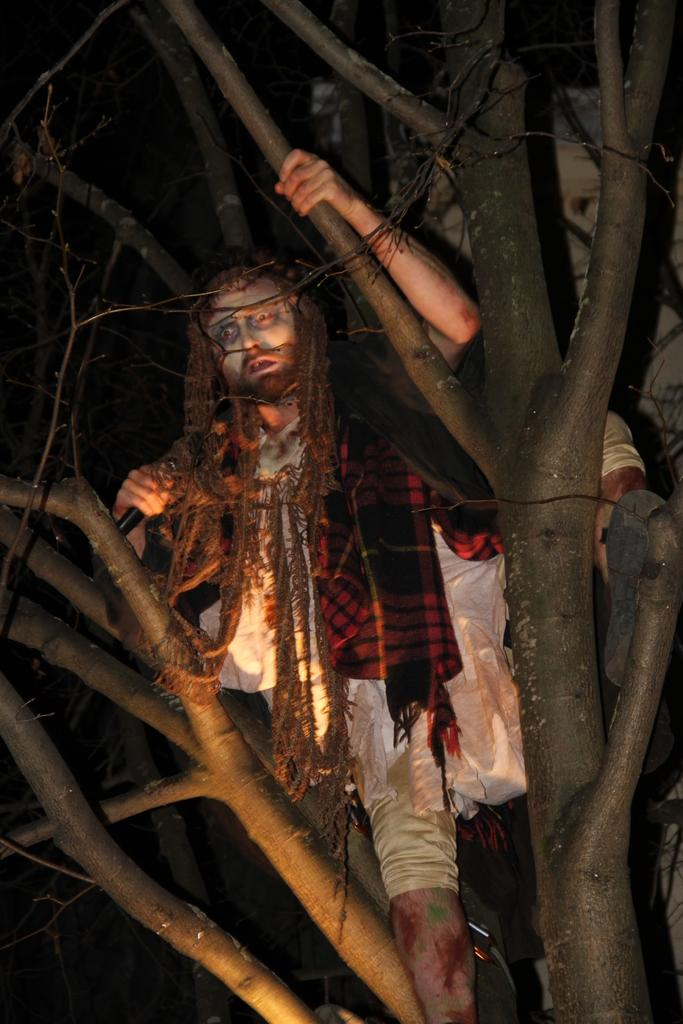Who or what is present in the image? There is a person in the image. What is the person wearing? The person is wearing a costume with different colors. Where is the person standing? The person is standing on a tree. What is the color of the background in the image? The background of the image is black. How many crows can be seen in the image? There are no crows present in the image. What type of expansion is taking place in the image? There is no expansion taking place in the image. 